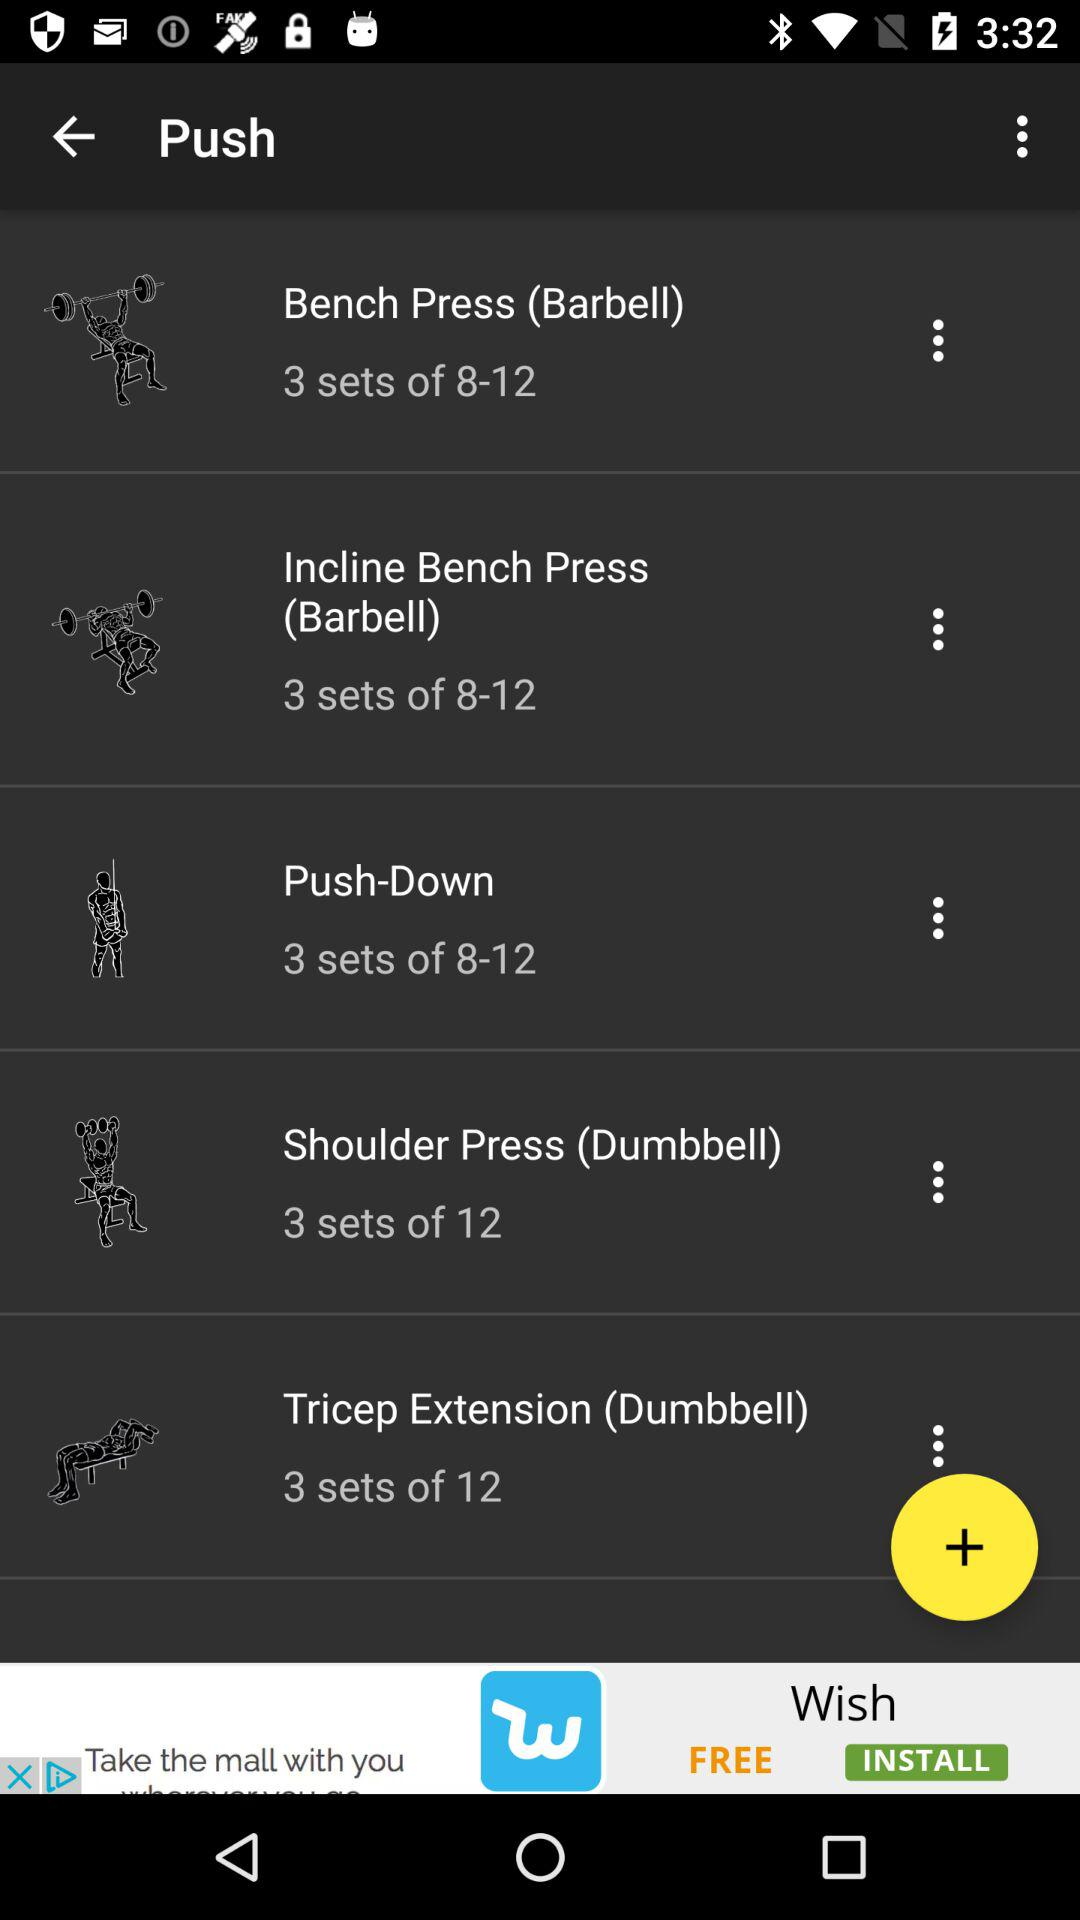How many total sets of "Shoulder Press (Dumbbell)" are allowed? A total of 12 sets is allowed. 